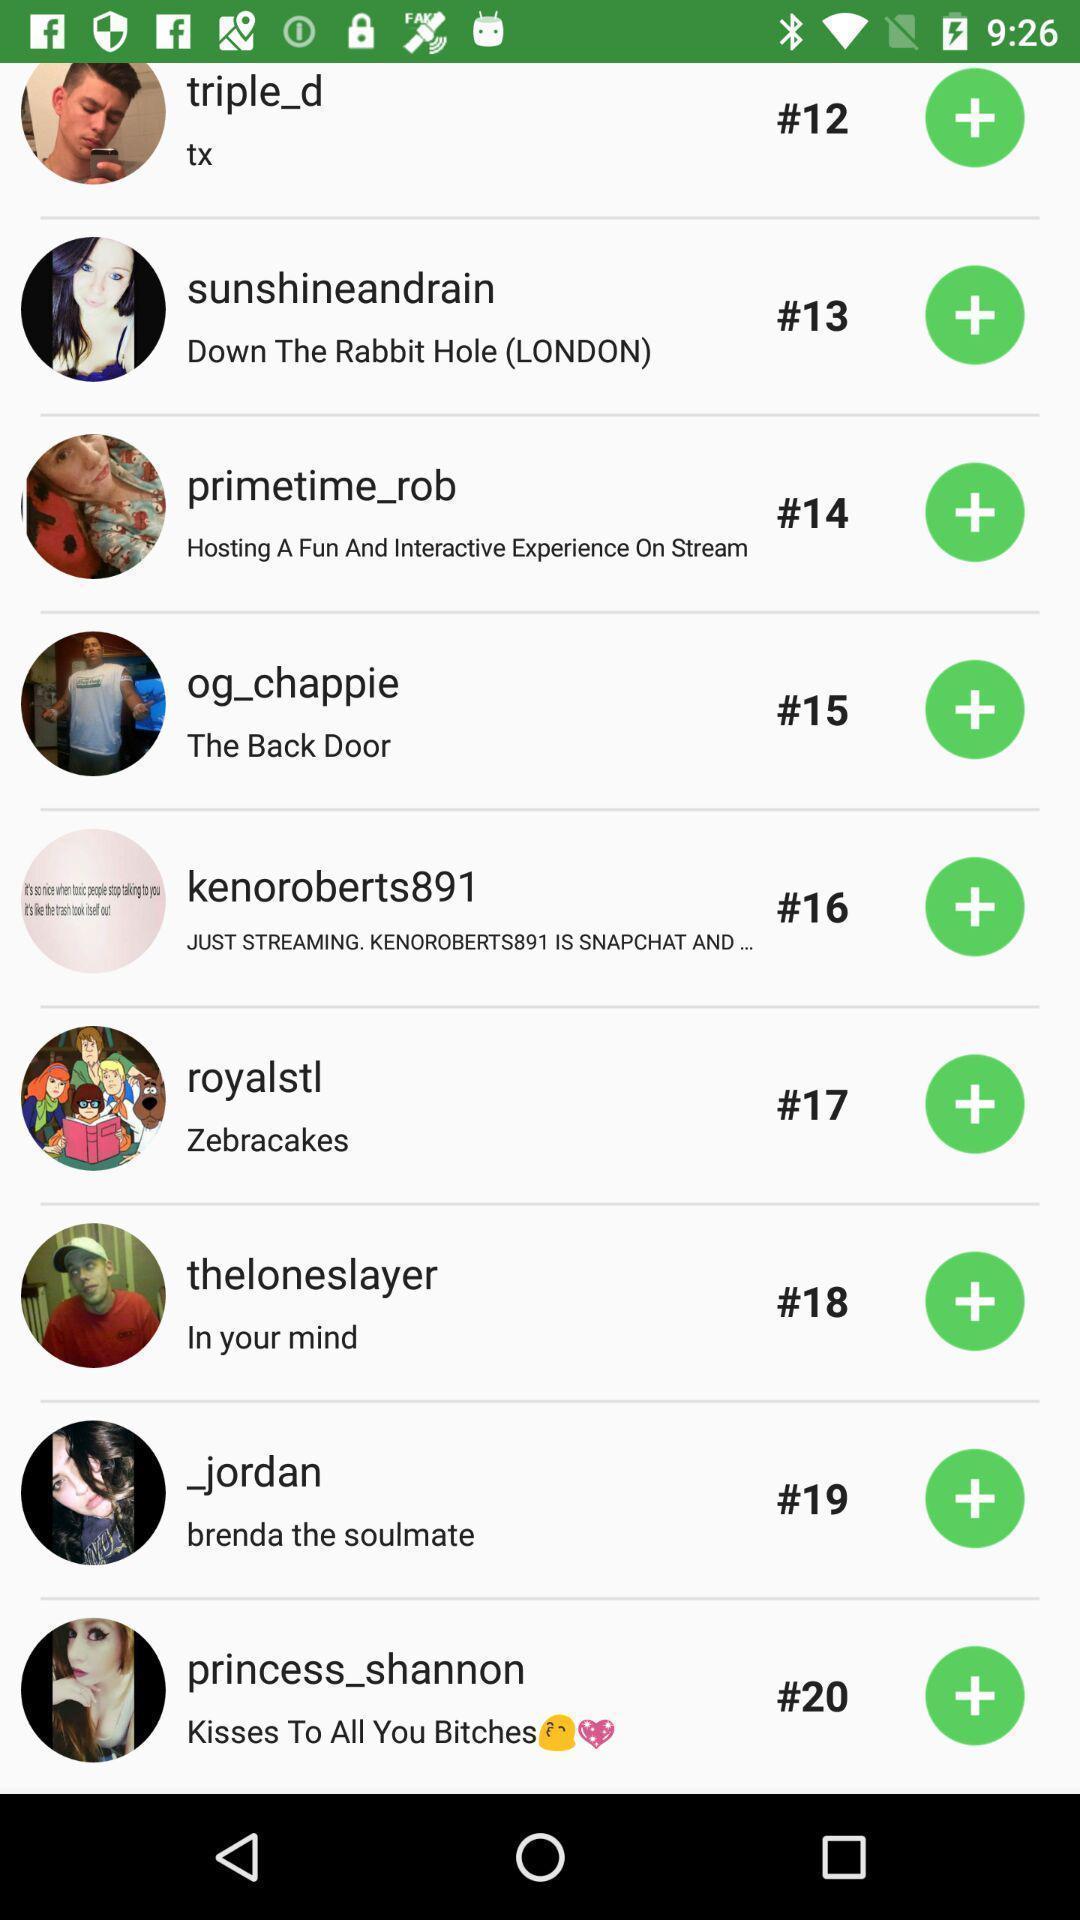Summarize the information in this screenshot. Page showing different people on a social app. 